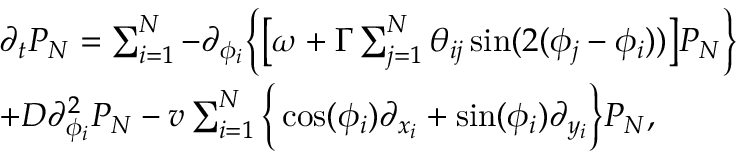Convert formula to latex. <formula><loc_0><loc_0><loc_500><loc_500>\begin{array} { r l } & { \partial _ { t } P _ { N } = \sum _ { i = 1 } ^ { N } - \partial _ { \phi _ { i } } \left \{ \left [ \omega + \Gamma \sum _ { j = 1 } ^ { N } \theta _ { i j } \sin ( 2 ( \phi _ { j } - \phi _ { i } ) ) \right ] P _ { N } \right \} } \\ & { + D \partial _ { \phi _ { i } } ^ { 2 } P _ { N } - v \sum _ { i = 1 } ^ { N } \left \{ \cos ( \phi _ { i } ) \partial _ { x _ { i } } + \sin ( \phi _ { i } ) \partial _ { y _ { i } } \right \} P _ { N } , } \end{array}</formula> 